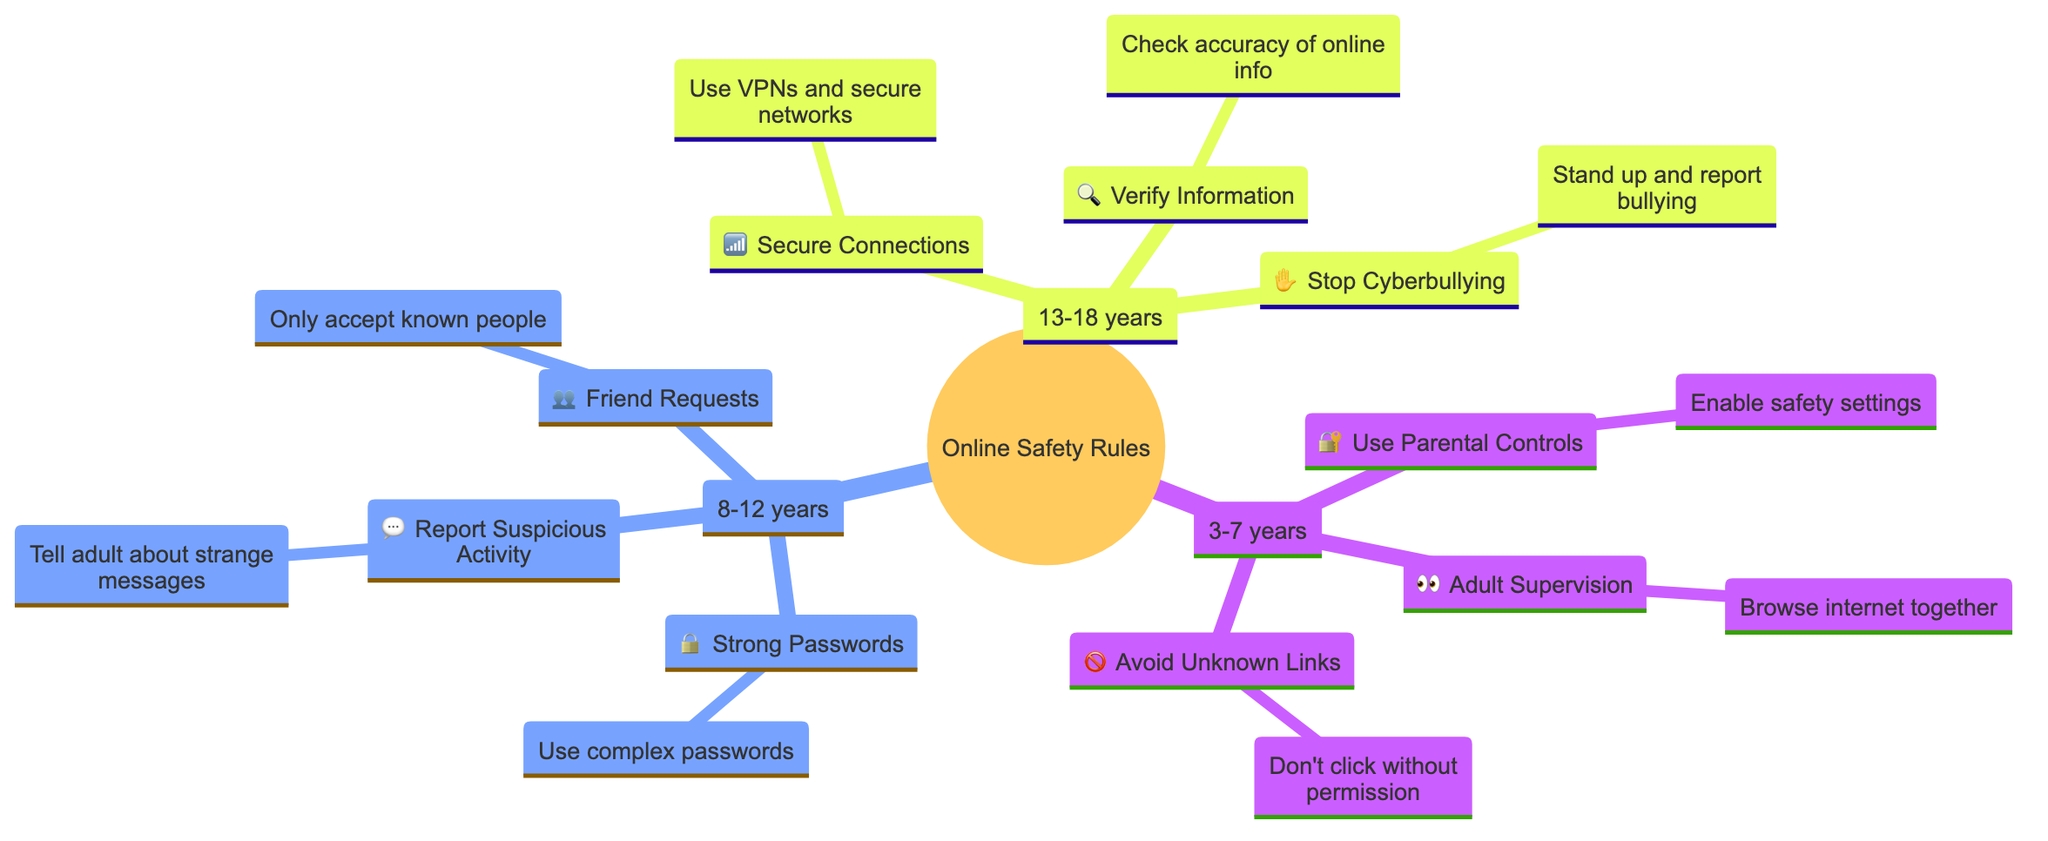What age group is associated with using parental controls? The diagram shows that "Use Parental Controls" is listed under the category "3-7 years," indicating this is the associated age group for this rule.
Answer: 3-7 years How many main age-specific categories does the diagram include? The diagram has three main categories for age groups: "3-7 years," "8-12 years," and "13-18 years." Therefore, the number of main categories is three.
Answer: 3 What is the icon used for "Report Suspicious Activity"? The diagram presents a speech bubble icon (💬) next to the rule "Report Suspicious Activity," identifying this visual representation.
Answer: 💬 Which rule is associated with the age group 8-12 years and involves password security? The diagram highlights "Strong Passwords" under the age group "8-12 years," showing this specific rule relates to password security.
Answer: Strong Passwords What action should be taken if an unknown link is found according to the 3-7 years category? The diagram states the action related to unknown links as "Don't click without permission," hence this is the recommended action.
Answer: Don't click without permission How are cyberbullying and verification of information related in the age category 13-18 years? Both "Stop Cyberbullying" and "Verify Information" are rules associated with the age category "13-18 years." This indicates that adolescents in this age range should be aware of both the importance of verifying information and addressing cyberbullying.
Answer: 13-18 years What is the visual representation for the rule "Secure Connections"? The diagram uses a Wi-Fi signal icon (📶) to represent "Secure Connections," providing a clear visual cue for this rule.
Answer: 📶 How many specific rules are listed under the age category of 8-12 years? When examining the 8-12 years category in the diagram, it shows that there are three specific rules: "Strong Passwords," "Report Suspicious Activity," and "Friend Requests." Therefore, the total is three rules.
Answer: 3 Which icon is used for "Adult Supervision" in the 3-7 years category? The diagram features an eye icon (👀) next to "Adult Supervision," indicating how this rule is visually represented.
Answer: 👀 